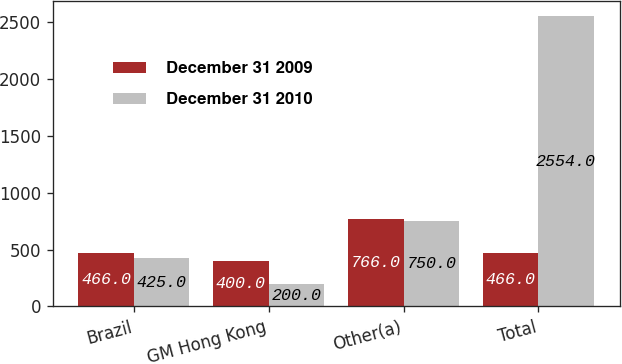<chart> <loc_0><loc_0><loc_500><loc_500><stacked_bar_chart><ecel><fcel>Brazil<fcel>GM Hong Kong<fcel>Other(a)<fcel>Total<nl><fcel>December 31 2009<fcel>466<fcel>400<fcel>766<fcel>466<nl><fcel>December 31 2010<fcel>425<fcel>200<fcel>750<fcel>2554<nl></chart> 